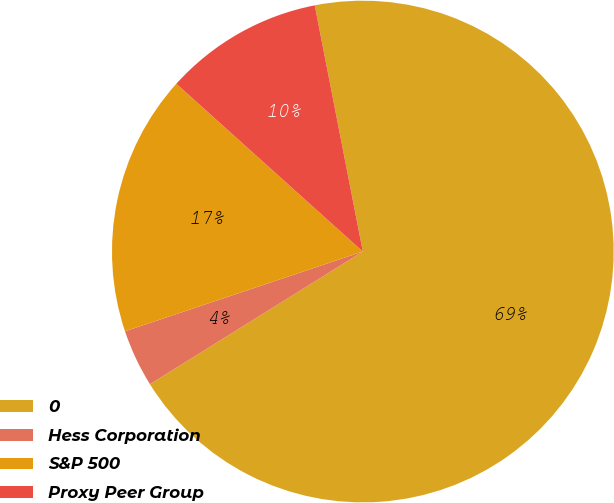Convert chart. <chart><loc_0><loc_0><loc_500><loc_500><pie_chart><fcel>0<fcel>Hess Corporation<fcel>S&P 500<fcel>Proxy Peer Group<nl><fcel>69.2%<fcel>3.72%<fcel>16.81%<fcel>10.27%<nl></chart> 